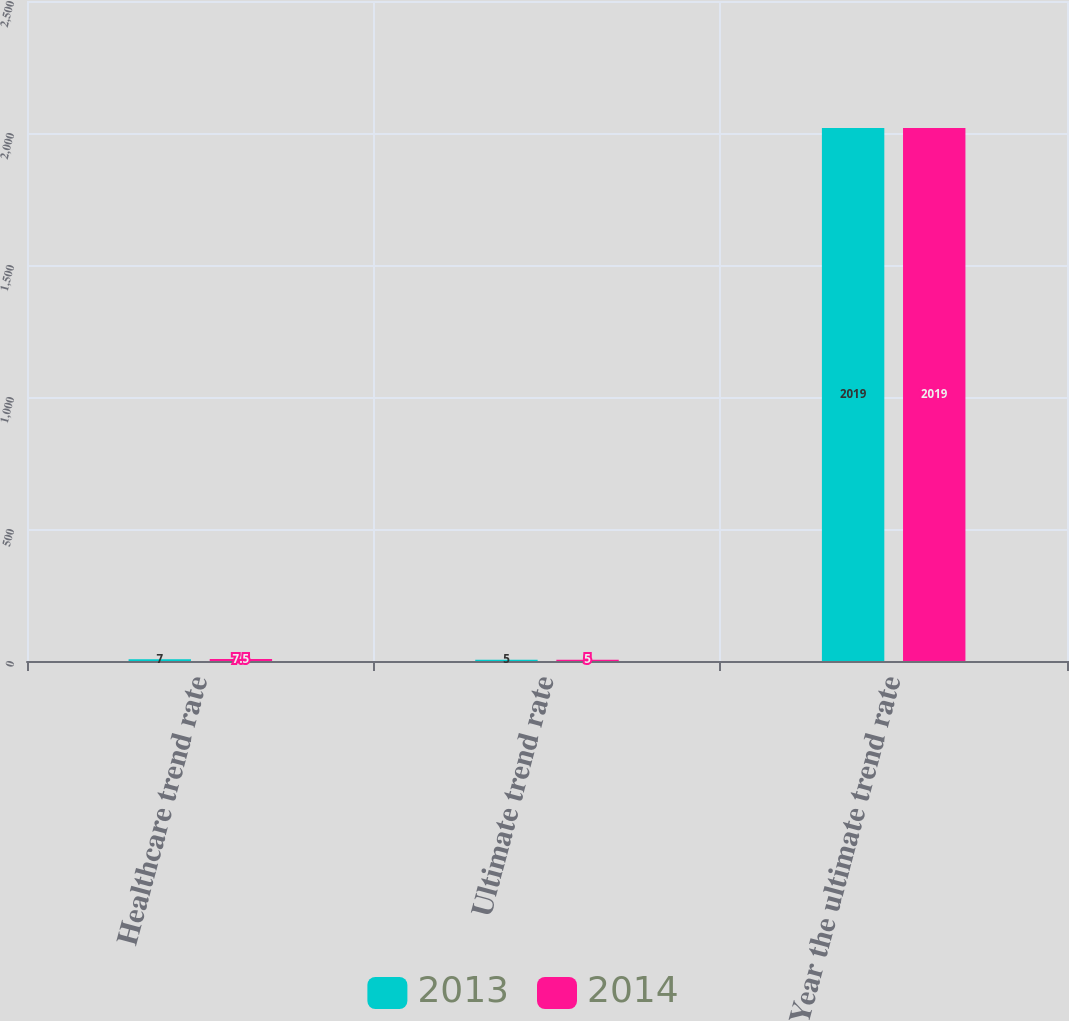Convert chart to OTSL. <chart><loc_0><loc_0><loc_500><loc_500><stacked_bar_chart><ecel><fcel>Healthcare trend rate<fcel>Ultimate trend rate<fcel>Year the ultimate trend rate<nl><fcel>2013<fcel>7<fcel>5<fcel>2019<nl><fcel>2014<fcel>7.5<fcel>5<fcel>2019<nl></chart> 